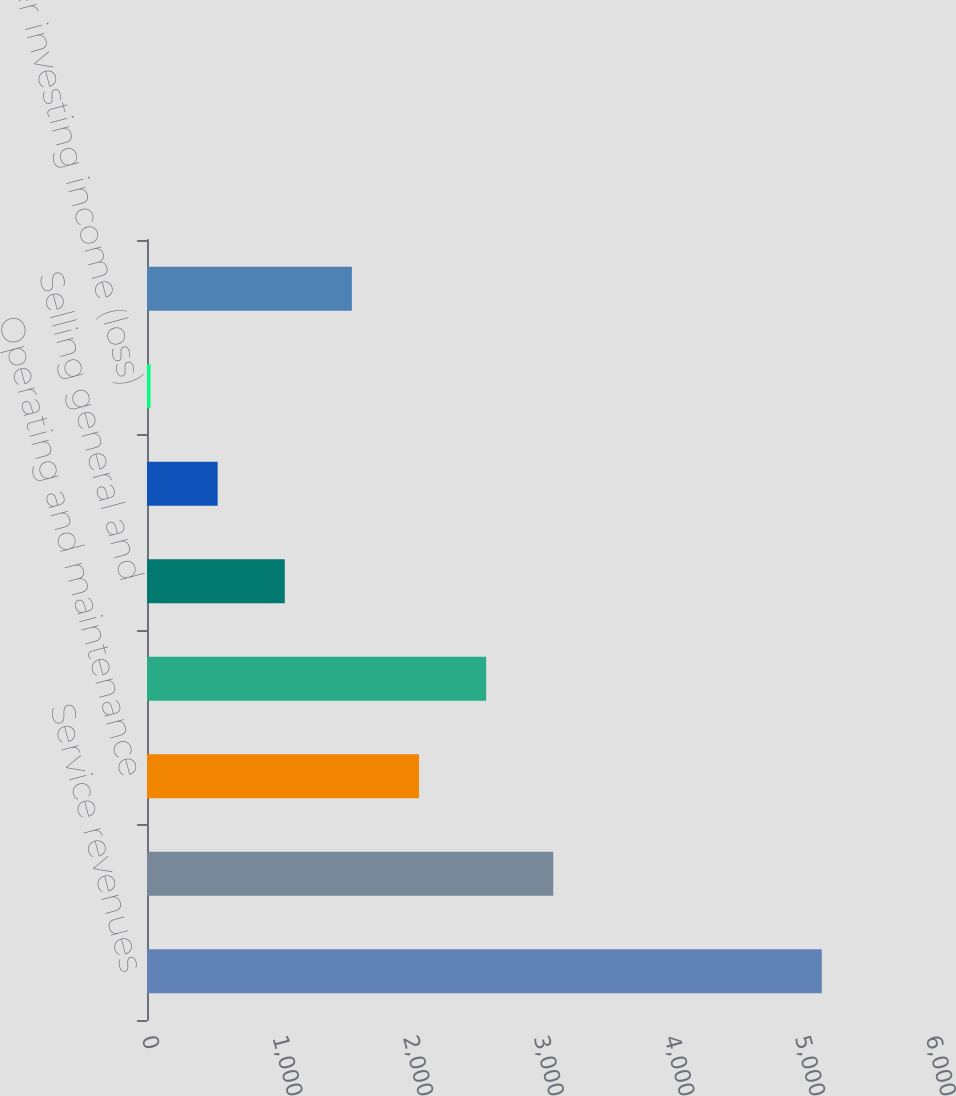Convert chart to OTSL. <chart><loc_0><loc_0><loc_500><loc_500><bar_chart><fcel>Service revenues<fcel>Product sales<fcel>Operating and maintenance<fcel>Depreciation and amortization<fcel>Selling general and<fcel>Equity earnings (losses)<fcel>Other investing income (loss)<fcel>Interest expense<nl><fcel>5164<fcel>3109.2<fcel>2081.8<fcel>2595.5<fcel>1054.4<fcel>540.7<fcel>27<fcel>1568.1<nl></chart> 